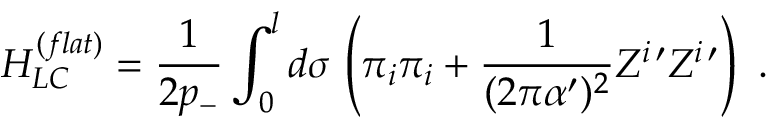Convert formula to latex. <formula><loc_0><loc_0><loc_500><loc_500>H _ { L C } ^ { ( f l a t ) } = \frac { 1 } { 2 p _ { - } } \int _ { 0 } ^ { l } d \sigma \, \left ( \pi _ { i } \pi _ { i } + \frac { 1 } { ( 2 \pi \alpha ^ { \prime } ) ^ { 2 } } Z ^ { i \, \prime } Z ^ { i \, \prime } \right ) \ .</formula> 